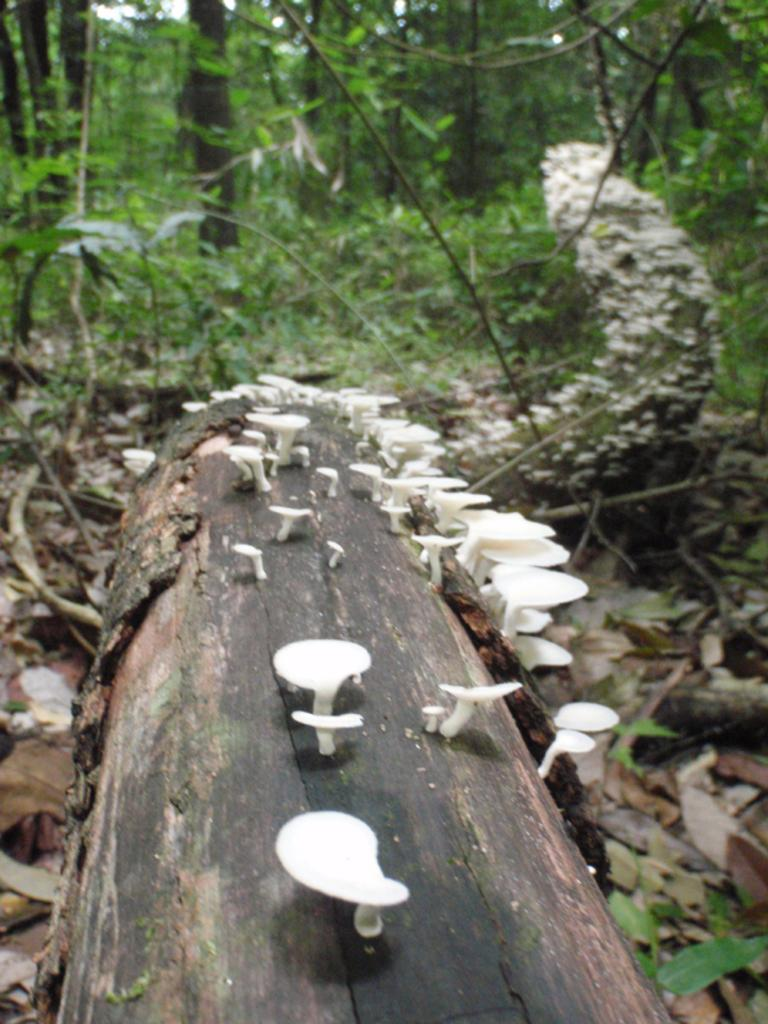What is the main subject of the image? The main subject of the image is a tree trunk. What other objects can be seen near the tree trunk? There are mushrooms and plants visible in the image. What can be seen in the background of the image? There are trees in the background of the image. How would you describe the appearance of the backdrop in the image? The backdrop of the image is blurred. How does the rice contribute to the growth of the mushrooms in the image? There is no rice present in the image, so it cannot contribute to the growth of the mushrooms. 